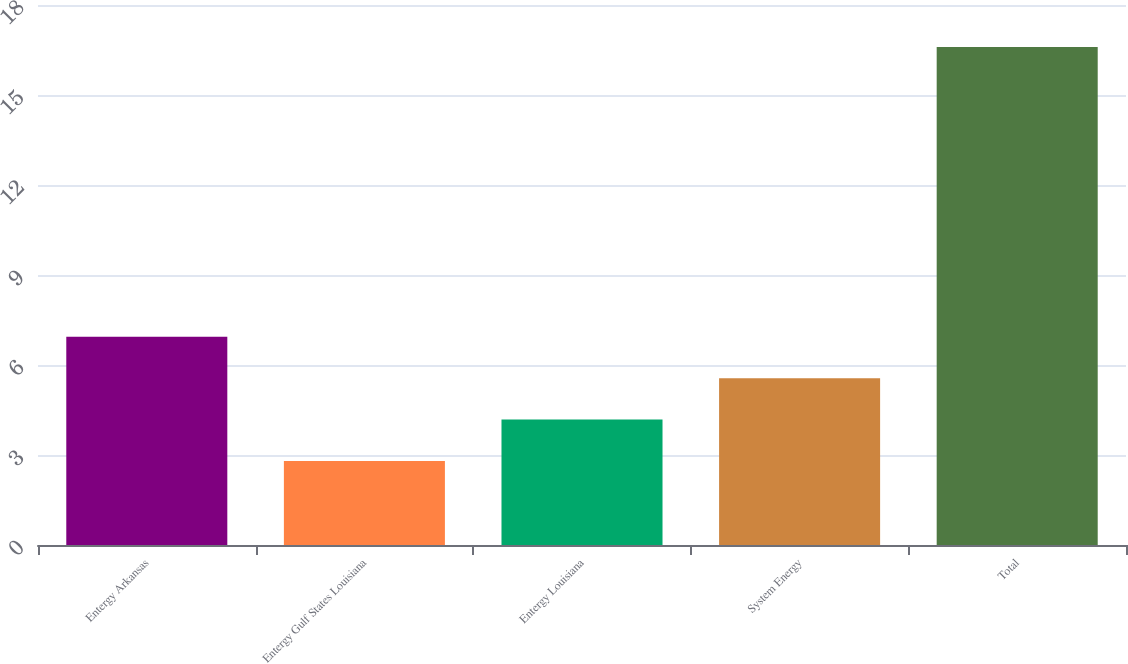Convert chart to OTSL. <chart><loc_0><loc_0><loc_500><loc_500><bar_chart><fcel>Entergy Arkansas<fcel>Entergy Gulf States Louisiana<fcel>Entergy Louisiana<fcel>System Energy<fcel>Total<nl><fcel>6.94<fcel>2.8<fcel>4.18<fcel>5.56<fcel>16.6<nl></chart> 